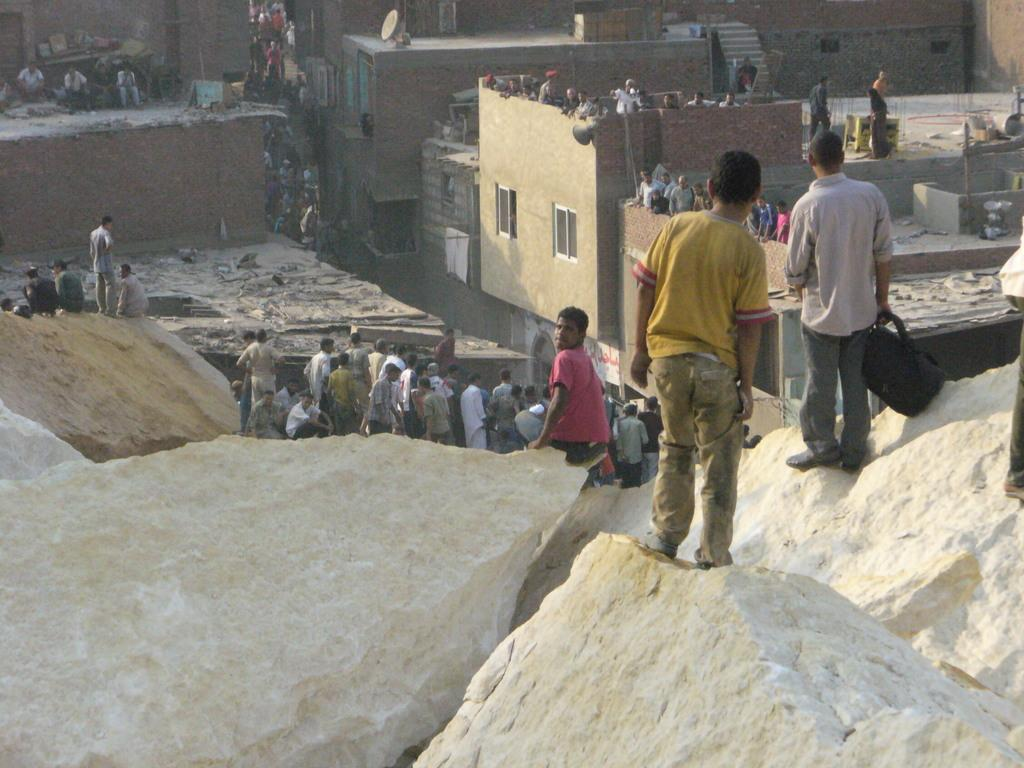How many people are in the group shown in the image? There is a group of people in the image, but the exact number is not specified. What is the color of the shirt worn by one person in the group? One person in the group is wearing a red shirt. What can be seen in the background of the image? There are buildings visible in the background of the image. What colors are the buildings in the background? The buildings have brown and cream colors. Can you tell me how many goldfish are swimming in the fountain in the image? There is no fountain or goldfish present in the image. What type of expansion is taking place in the image? There is no indication of any expansion in the image. 